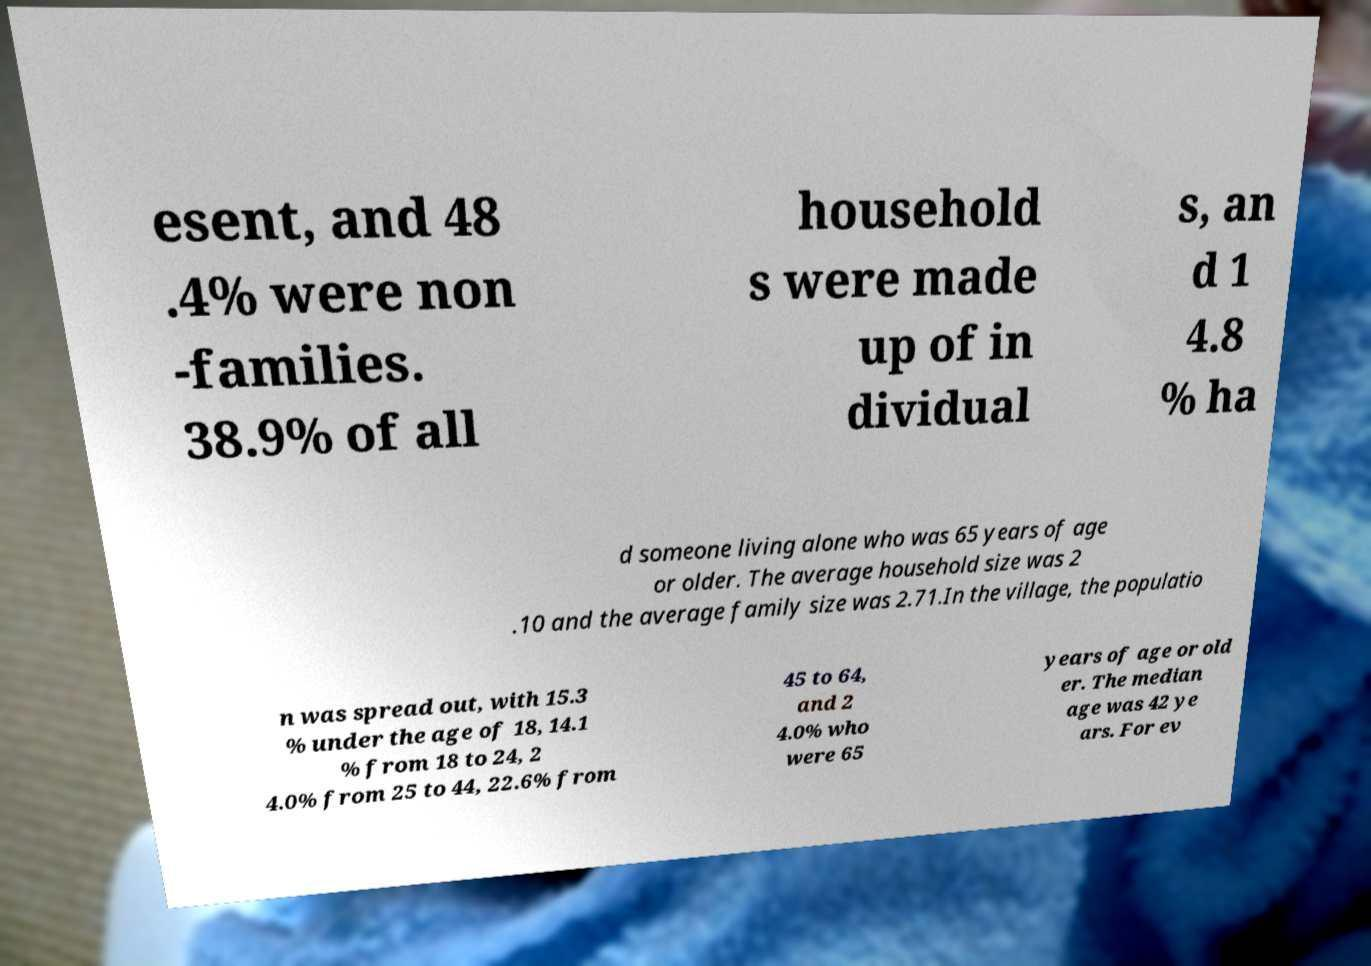There's text embedded in this image that I need extracted. Can you transcribe it verbatim? esent, and 48 .4% were non -families. 38.9% of all household s were made up of in dividual s, an d 1 4.8 % ha d someone living alone who was 65 years of age or older. The average household size was 2 .10 and the average family size was 2.71.In the village, the populatio n was spread out, with 15.3 % under the age of 18, 14.1 % from 18 to 24, 2 4.0% from 25 to 44, 22.6% from 45 to 64, and 2 4.0% who were 65 years of age or old er. The median age was 42 ye ars. For ev 